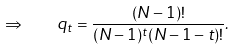<formula> <loc_0><loc_0><loc_500><loc_500>\Rightarrow \quad q _ { t } = \frac { ( N - 1 ) ! } { ( N - 1 ) ^ { t } ( N - 1 - t ) ! } .</formula> 